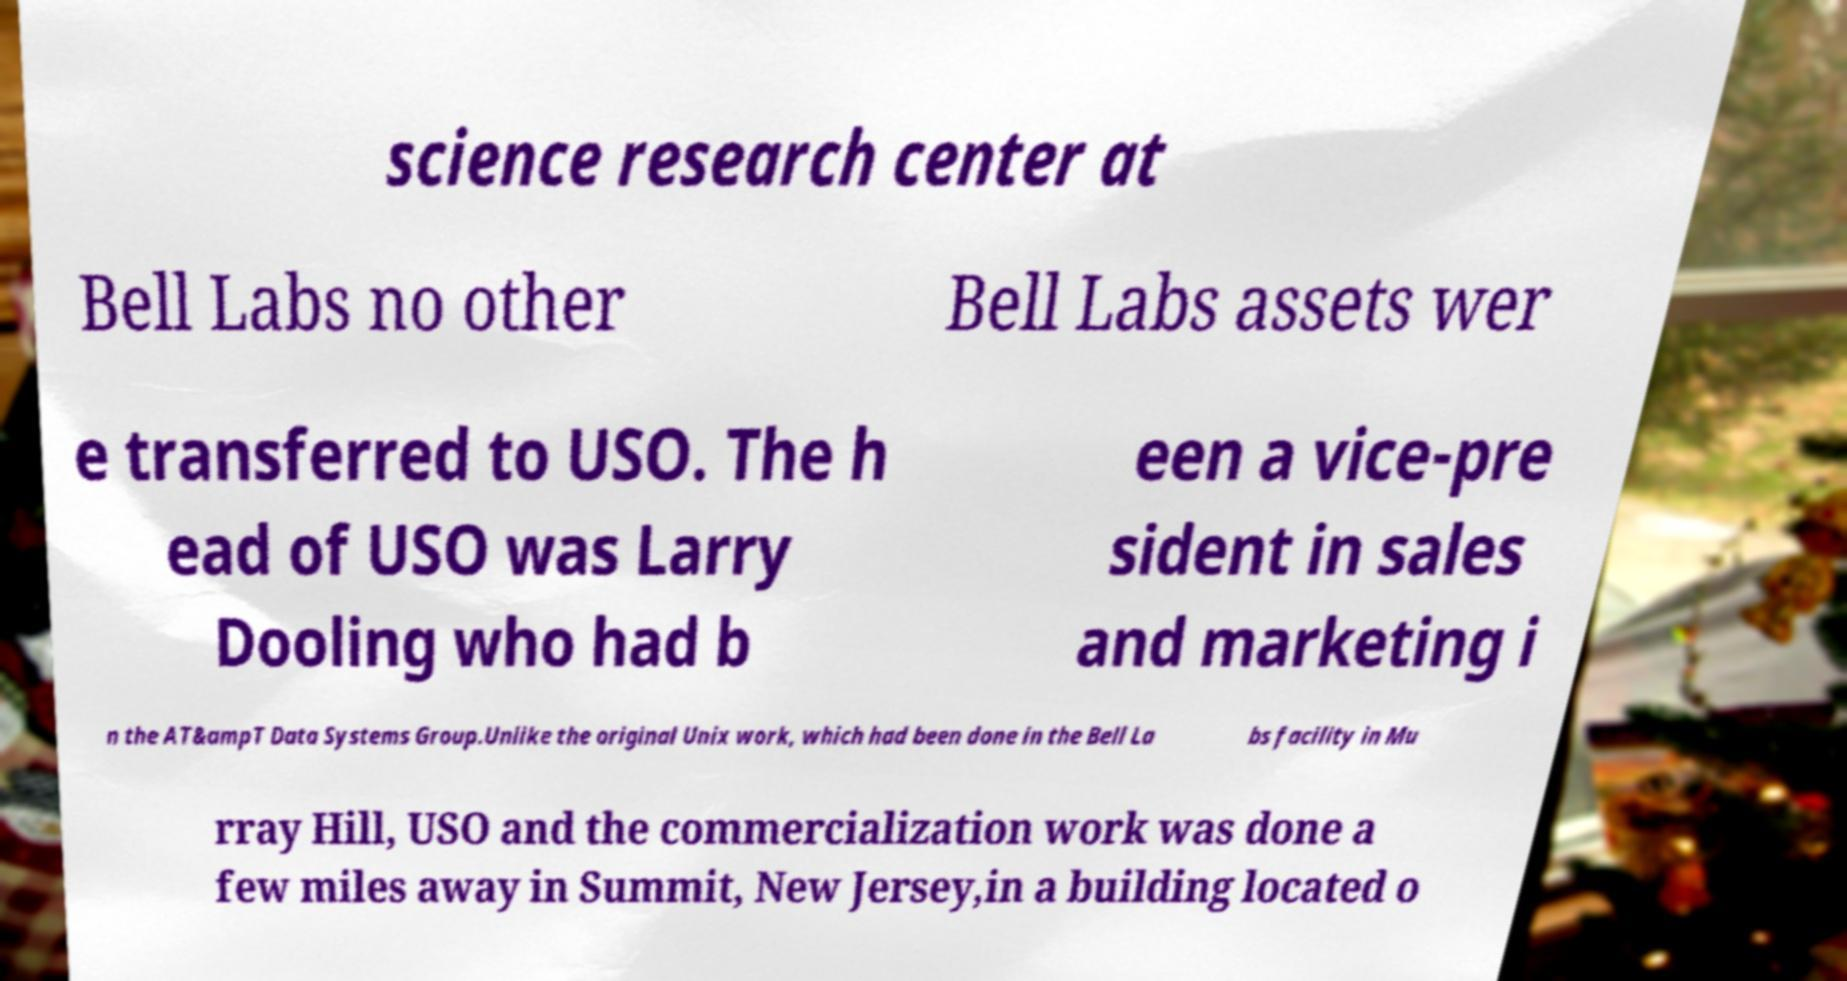Can you read and provide the text displayed in the image?This photo seems to have some interesting text. Can you extract and type it out for me? science research center at Bell Labs no other Bell Labs assets wer e transferred to USO. The h ead of USO was Larry Dooling who had b een a vice-pre sident in sales and marketing i n the AT&ampT Data Systems Group.Unlike the original Unix work, which had been done in the Bell La bs facility in Mu rray Hill, USO and the commercialization work was done a few miles away in Summit, New Jersey,in a building located o 